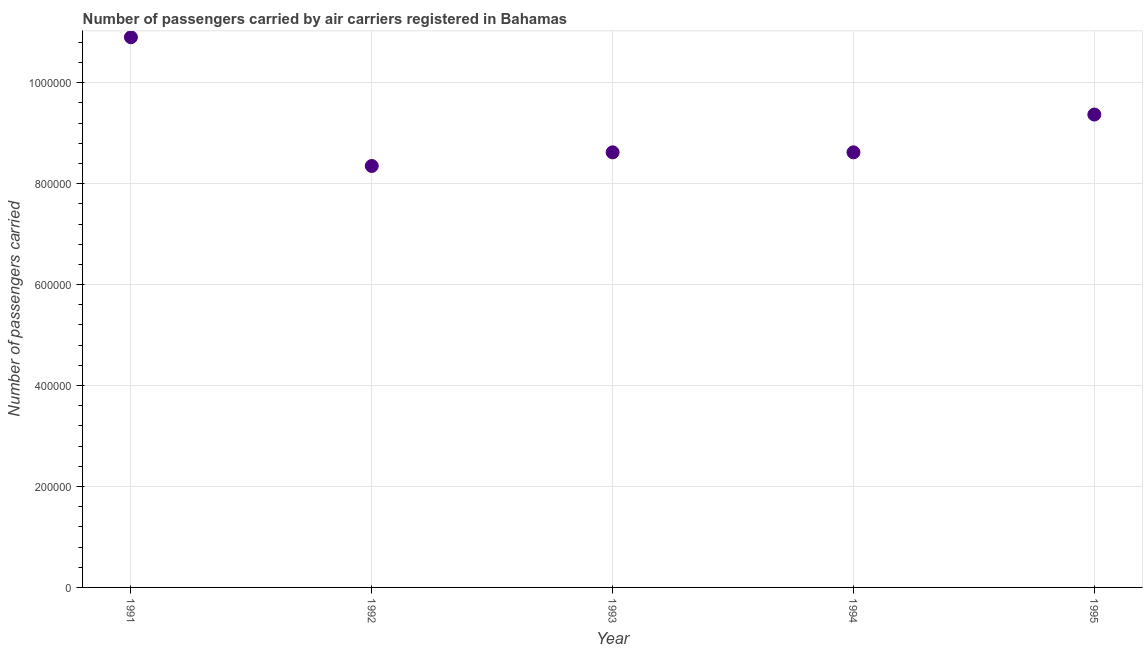What is the number of passengers carried in 1992?
Your answer should be compact. 8.35e+05. Across all years, what is the maximum number of passengers carried?
Offer a terse response. 1.09e+06. Across all years, what is the minimum number of passengers carried?
Your response must be concise. 8.35e+05. What is the sum of the number of passengers carried?
Keep it short and to the point. 4.59e+06. What is the difference between the number of passengers carried in 1993 and 1994?
Give a very brief answer. 0. What is the average number of passengers carried per year?
Your response must be concise. 9.17e+05. What is the median number of passengers carried?
Keep it short and to the point. 8.62e+05. Do a majority of the years between 1995 and 1991 (inclusive) have number of passengers carried greater than 40000 ?
Give a very brief answer. Yes. What is the ratio of the number of passengers carried in 1994 to that in 1995?
Keep it short and to the point. 0.92. Is the number of passengers carried in 1991 less than that in 1992?
Your answer should be compact. No. What is the difference between the highest and the second highest number of passengers carried?
Ensure brevity in your answer.  1.53e+05. Is the sum of the number of passengers carried in 1992 and 1993 greater than the maximum number of passengers carried across all years?
Offer a terse response. Yes. What is the difference between the highest and the lowest number of passengers carried?
Your answer should be very brief. 2.55e+05. Does the number of passengers carried monotonically increase over the years?
Ensure brevity in your answer.  No. How many years are there in the graph?
Your answer should be compact. 5. What is the title of the graph?
Your answer should be compact. Number of passengers carried by air carriers registered in Bahamas. What is the label or title of the X-axis?
Your answer should be compact. Year. What is the label or title of the Y-axis?
Provide a short and direct response. Number of passengers carried. What is the Number of passengers carried in 1991?
Give a very brief answer. 1.09e+06. What is the Number of passengers carried in 1992?
Provide a succinct answer. 8.35e+05. What is the Number of passengers carried in 1993?
Offer a terse response. 8.62e+05. What is the Number of passengers carried in 1994?
Give a very brief answer. 8.62e+05. What is the Number of passengers carried in 1995?
Provide a short and direct response. 9.37e+05. What is the difference between the Number of passengers carried in 1991 and 1992?
Give a very brief answer. 2.55e+05. What is the difference between the Number of passengers carried in 1991 and 1993?
Offer a very short reply. 2.28e+05. What is the difference between the Number of passengers carried in 1991 and 1994?
Provide a succinct answer. 2.28e+05. What is the difference between the Number of passengers carried in 1991 and 1995?
Keep it short and to the point. 1.53e+05. What is the difference between the Number of passengers carried in 1992 and 1993?
Provide a short and direct response. -2.70e+04. What is the difference between the Number of passengers carried in 1992 and 1994?
Keep it short and to the point. -2.70e+04. What is the difference between the Number of passengers carried in 1992 and 1995?
Ensure brevity in your answer.  -1.02e+05. What is the difference between the Number of passengers carried in 1993 and 1994?
Give a very brief answer. 0. What is the difference between the Number of passengers carried in 1993 and 1995?
Provide a succinct answer. -7.49e+04. What is the difference between the Number of passengers carried in 1994 and 1995?
Provide a succinct answer. -7.49e+04. What is the ratio of the Number of passengers carried in 1991 to that in 1992?
Offer a terse response. 1.3. What is the ratio of the Number of passengers carried in 1991 to that in 1993?
Your answer should be compact. 1.26. What is the ratio of the Number of passengers carried in 1991 to that in 1994?
Give a very brief answer. 1.26. What is the ratio of the Number of passengers carried in 1991 to that in 1995?
Your answer should be compact. 1.16. What is the ratio of the Number of passengers carried in 1992 to that in 1995?
Your response must be concise. 0.89. What is the ratio of the Number of passengers carried in 1993 to that in 1995?
Provide a short and direct response. 0.92. 